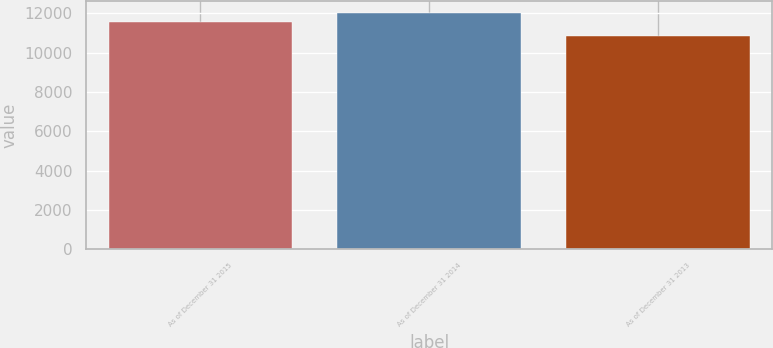Convert chart. <chart><loc_0><loc_0><loc_500><loc_500><bar_chart><fcel>As of December 31 2015<fcel>As of December 31 2014<fcel>As of December 31 2013<nl><fcel>11554<fcel>12032<fcel>10820<nl></chart> 